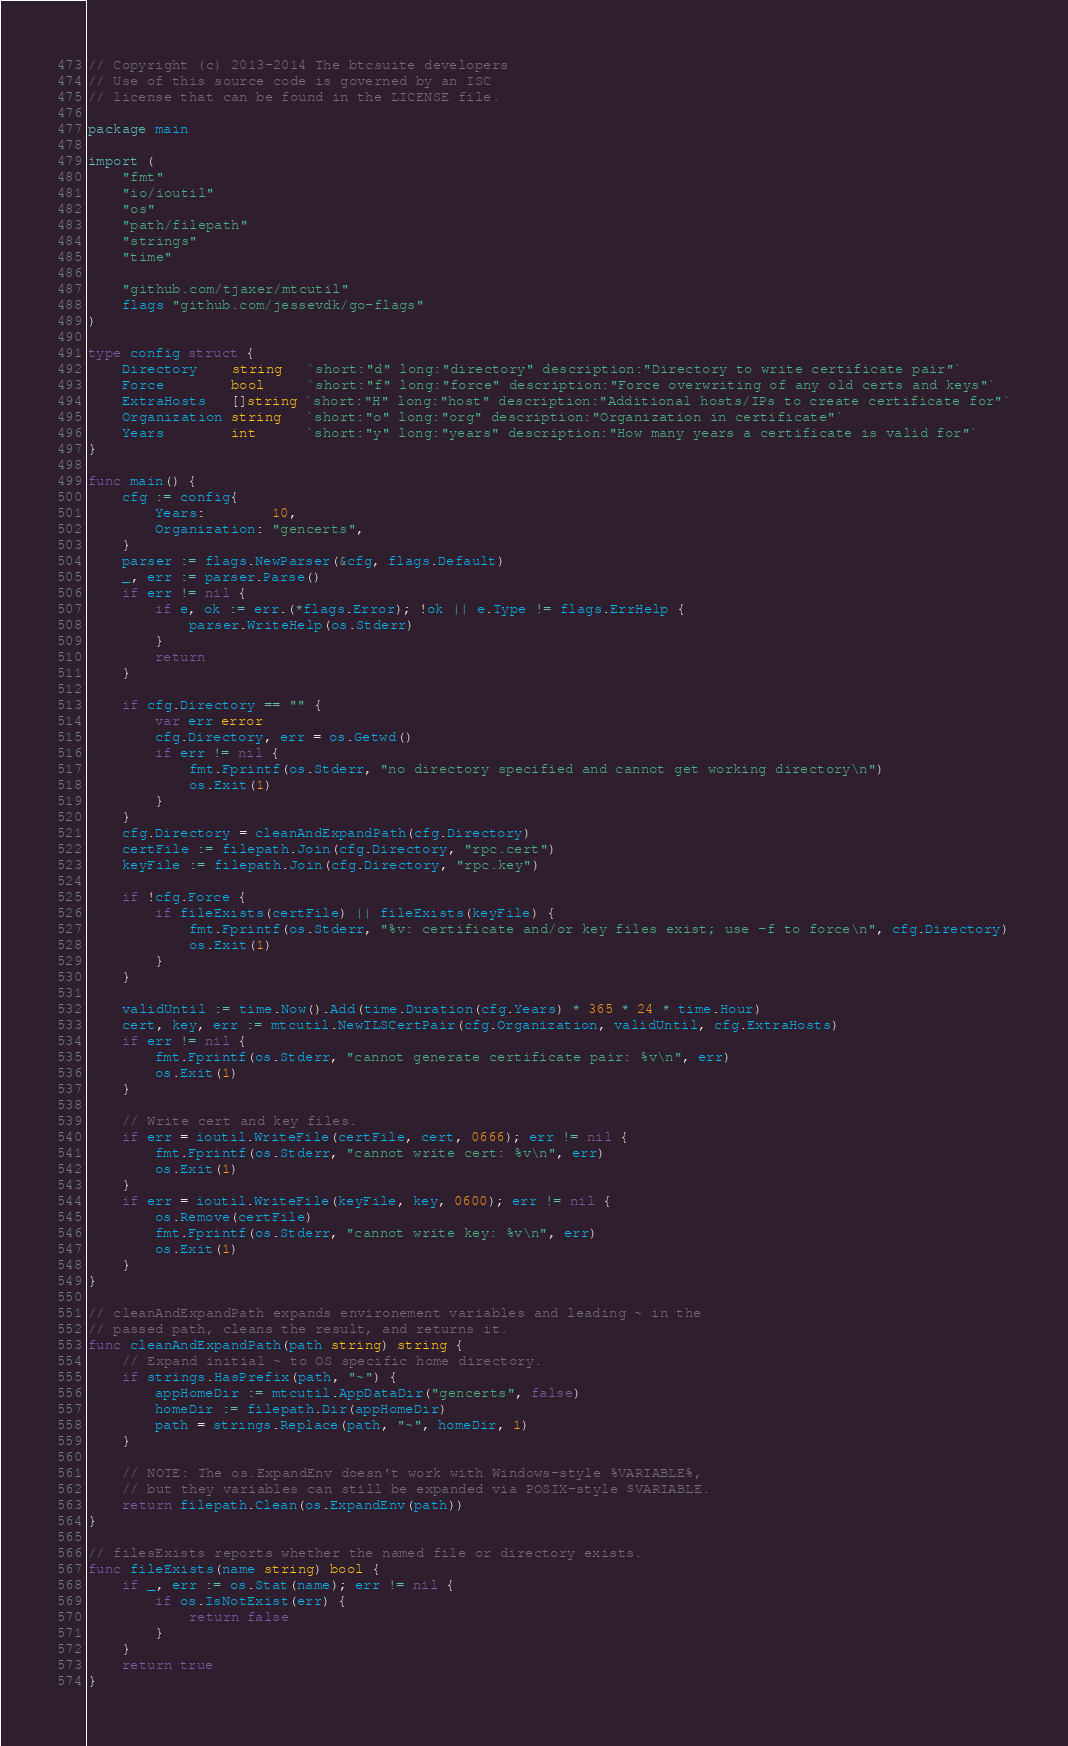Convert code to text. <code><loc_0><loc_0><loc_500><loc_500><_Go_>// Copyright (c) 2013-2014 The btcsuite developers
// Use of this source code is governed by an ISC
// license that can be found in the LICENSE file.

package main

import (
	"fmt"
	"io/ioutil"
	"os"
	"path/filepath"
	"strings"
	"time"

	"github.com/tjaxer/mtcutil"
	flags "github.com/jessevdk/go-flags"
)

type config struct {
	Directory    string   `short:"d" long:"directory" description:"Directory to write certificate pair"`
	Force        bool     `short:"f" long:"force" description:"Force overwriting of any old certs and keys"`
	ExtraHosts   []string `short:"H" long:"host" description:"Additional hosts/IPs to create certificate for"`
	Organization string   `short:"o" long:"org" description:"Organization in certificate"`
	Years        int      `short:"y" long:"years" description:"How many years a certificate is valid for"`
}

func main() {
	cfg := config{
		Years:        10,
		Organization: "gencerts",
	}
	parser := flags.NewParser(&cfg, flags.Default)
	_, err := parser.Parse()
	if err != nil {
		if e, ok := err.(*flags.Error); !ok || e.Type != flags.ErrHelp {
			parser.WriteHelp(os.Stderr)
		}
		return
	}

	if cfg.Directory == "" {
		var err error
		cfg.Directory, err = os.Getwd()
		if err != nil {
			fmt.Fprintf(os.Stderr, "no directory specified and cannot get working directory\n")
			os.Exit(1)
		}
	}
	cfg.Directory = cleanAndExpandPath(cfg.Directory)
	certFile := filepath.Join(cfg.Directory, "rpc.cert")
	keyFile := filepath.Join(cfg.Directory, "rpc.key")

	if !cfg.Force {
		if fileExists(certFile) || fileExists(keyFile) {
			fmt.Fprintf(os.Stderr, "%v: certificate and/or key files exist; use -f to force\n", cfg.Directory)
			os.Exit(1)
		}
	}

	validUntil := time.Now().Add(time.Duration(cfg.Years) * 365 * 24 * time.Hour)
	cert, key, err := mtcutil.NewTLSCertPair(cfg.Organization, validUntil, cfg.ExtraHosts)
	if err != nil {
		fmt.Fprintf(os.Stderr, "cannot generate certificate pair: %v\n", err)
		os.Exit(1)
	}

	// Write cert and key files.
	if err = ioutil.WriteFile(certFile, cert, 0666); err != nil {
		fmt.Fprintf(os.Stderr, "cannot write cert: %v\n", err)
		os.Exit(1)
	}
	if err = ioutil.WriteFile(keyFile, key, 0600); err != nil {
		os.Remove(certFile)
		fmt.Fprintf(os.Stderr, "cannot write key: %v\n", err)
		os.Exit(1)
	}
}

// cleanAndExpandPath expands environement variables and leading ~ in the
// passed path, cleans the result, and returns it.
func cleanAndExpandPath(path string) string {
	// Expand initial ~ to OS specific home directory.
	if strings.HasPrefix(path, "~") {
		appHomeDir := mtcutil.AppDataDir("gencerts", false)
		homeDir := filepath.Dir(appHomeDir)
		path = strings.Replace(path, "~", homeDir, 1)
	}

	// NOTE: The os.ExpandEnv doesn't work with Windows-style %VARIABLE%,
	// but they variables can still be expanded via POSIX-style $VARIABLE.
	return filepath.Clean(os.ExpandEnv(path))
}

// filesExists reports whether the named file or directory exists.
func fileExists(name string) bool {
	if _, err := os.Stat(name); err != nil {
		if os.IsNotExist(err) {
			return false
		}
	}
	return true
}
</code> 